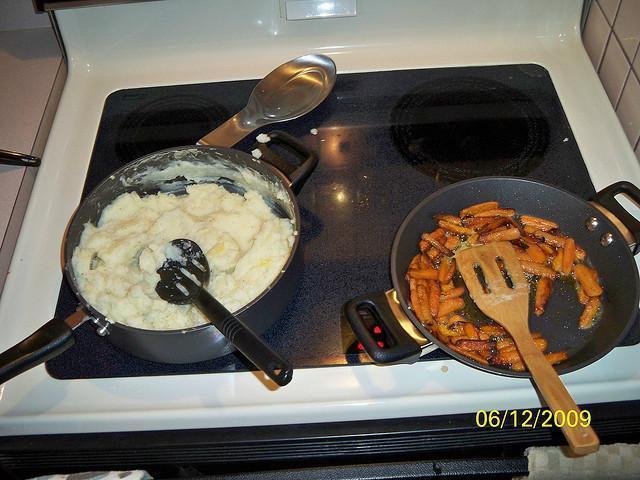How many spoons are in the photo?
Give a very brief answer. 2. 